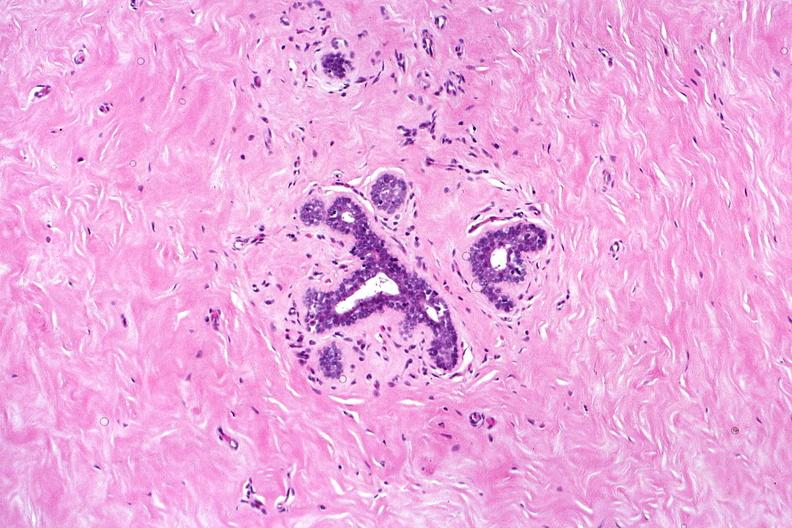s autoimmune thyroiditis present?
Answer the question using a single word or phrase. No 